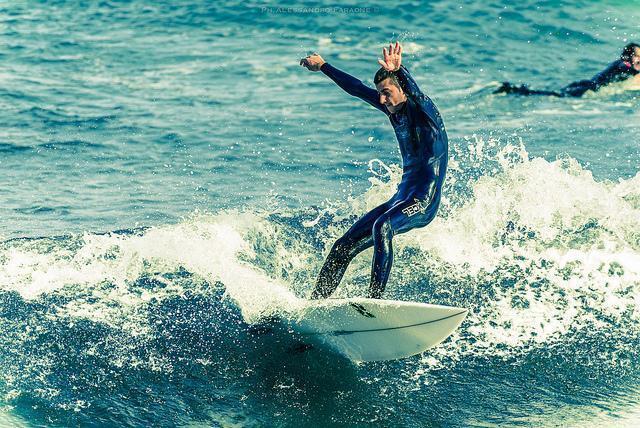How many fingers are spread on the surfer's hand?
Give a very brief answer. 5. How many people are there?
Give a very brief answer. 2. 